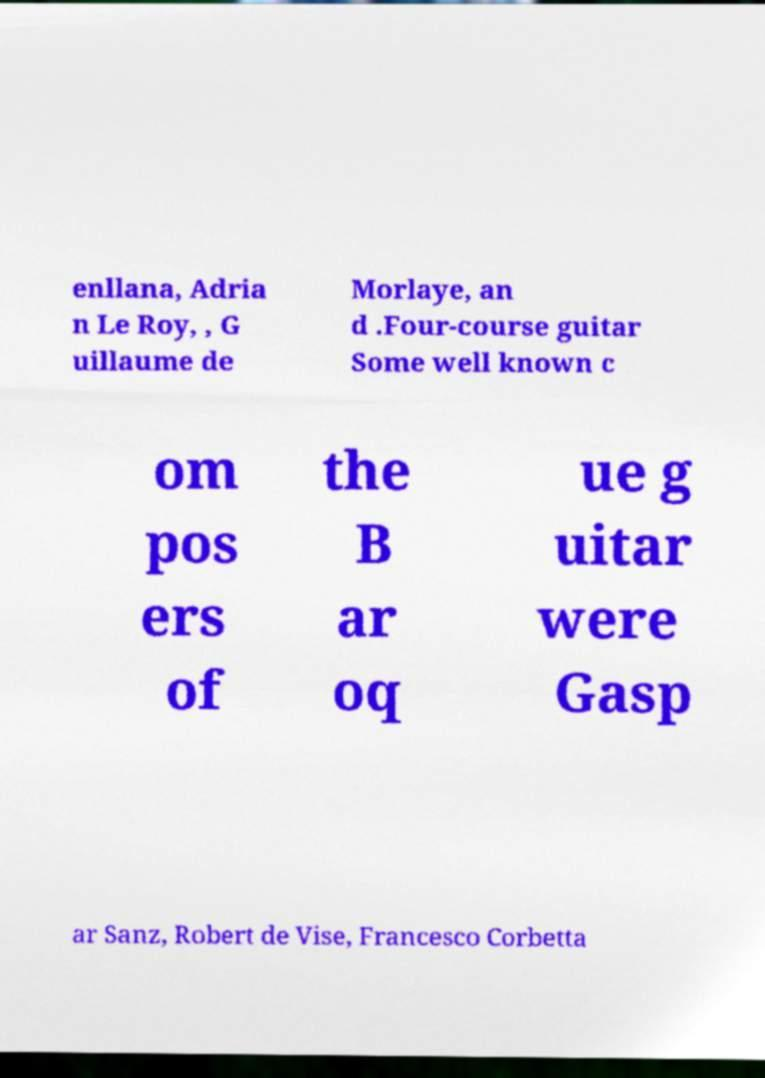For documentation purposes, I need the text within this image transcribed. Could you provide that? enllana, Adria n Le Roy, , G uillaume de Morlaye, an d .Four-course guitar Some well known c om pos ers of the B ar oq ue g uitar were Gasp ar Sanz, Robert de Vise, Francesco Corbetta 